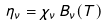Convert formula to latex. <formula><loc_0><loc_0><loc_500><loc_500>\eta _ { \nu } = \chi _ { \nu } \, B _ { \nu } ( T )</formula> 